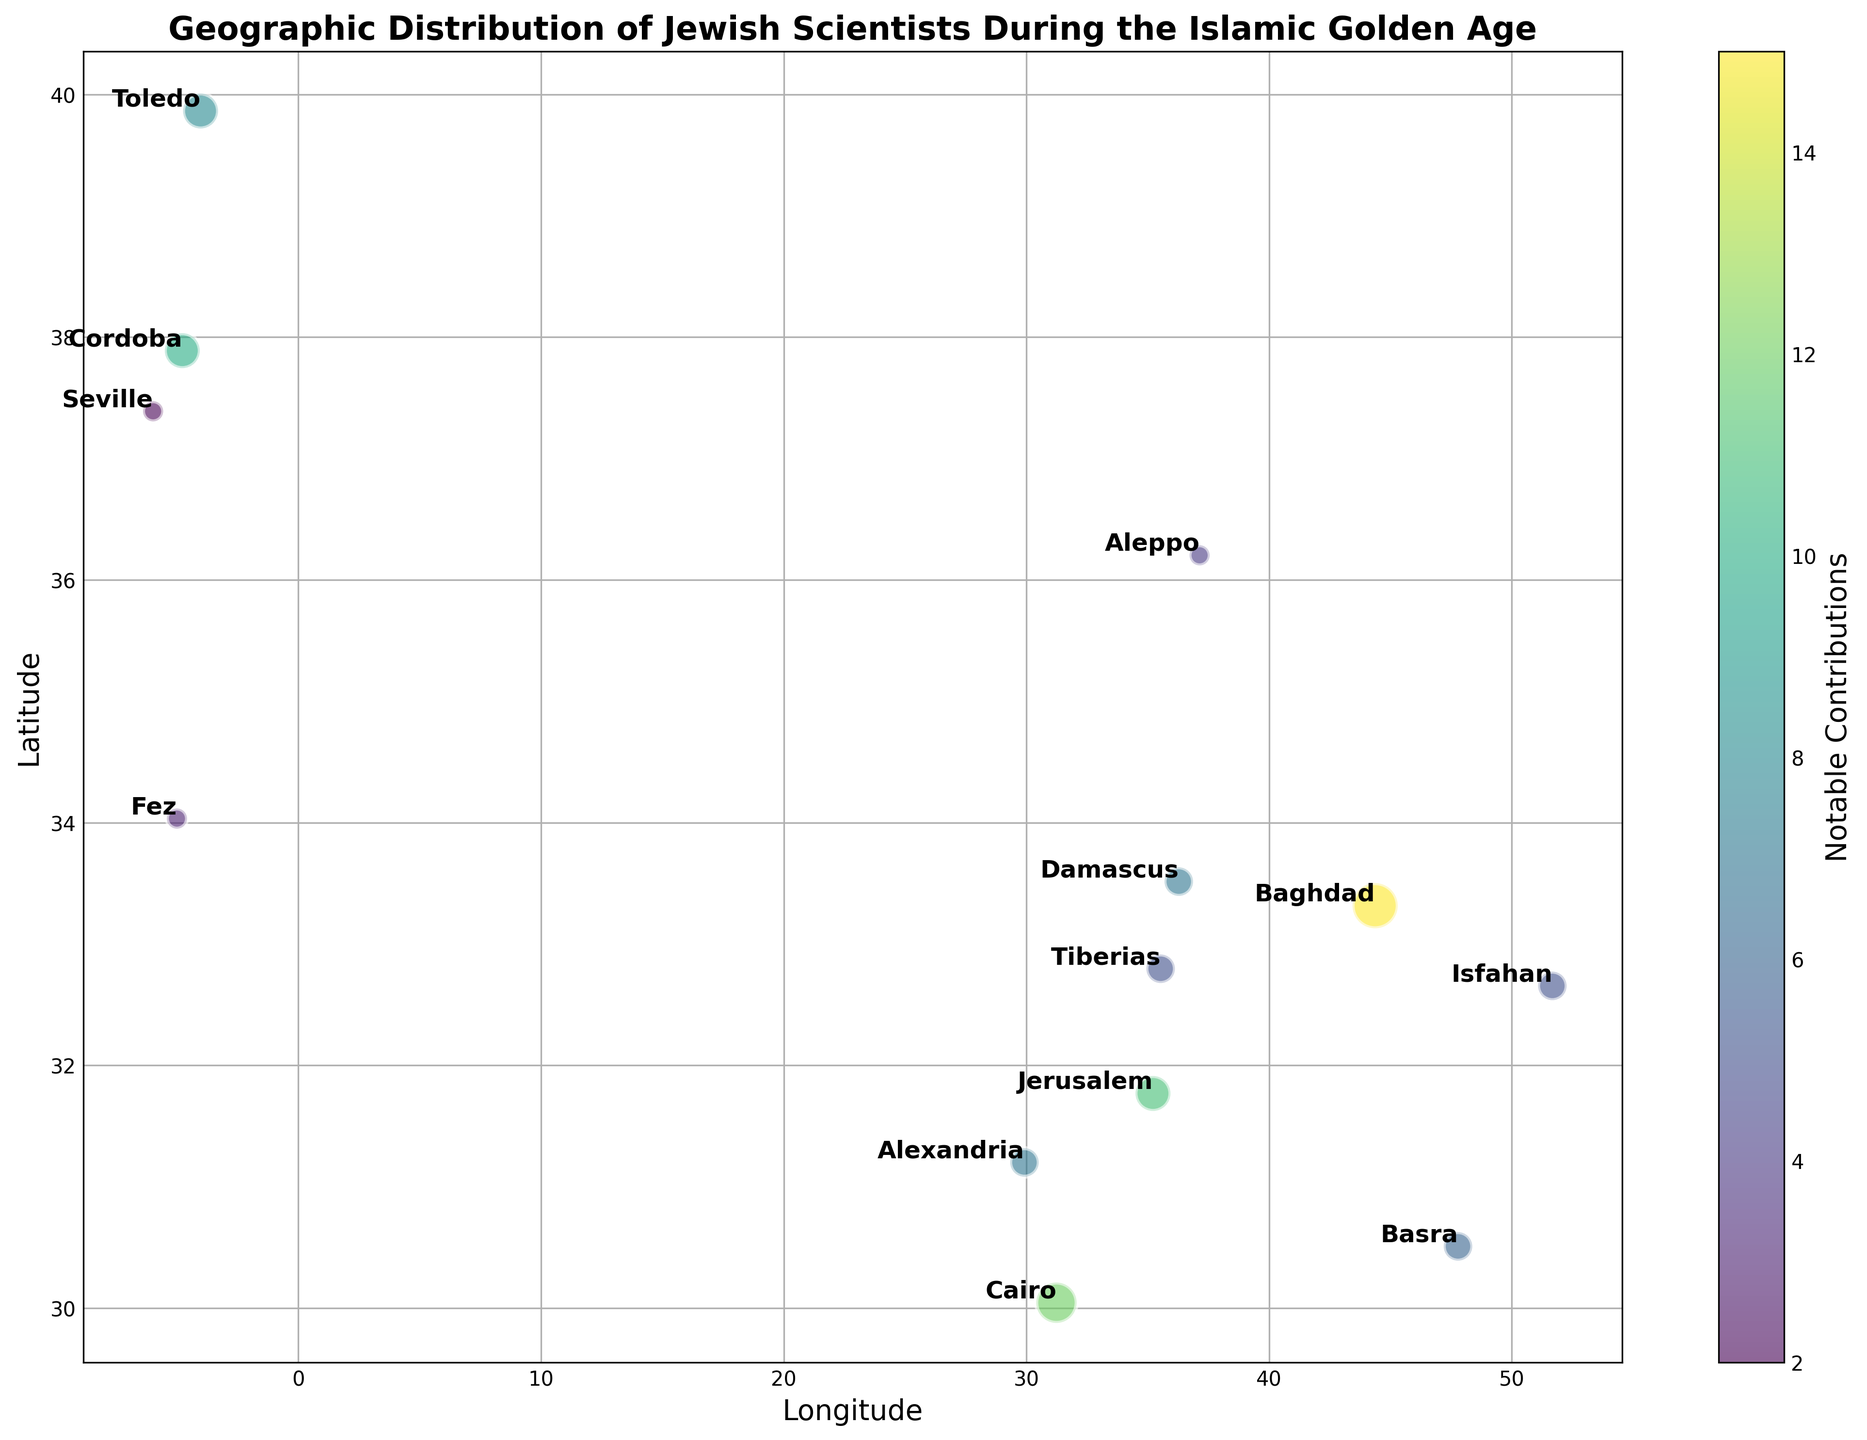What city has the highest number of Jewish scientists? Baghdad has the largest bubble size, indicating it has the highest number of Jewish scientists.
Answer: Baghdad Which city has the most notable contributions? Baghdad’s bubble is the darkest among all, indicating it has the highest notable contributions.
Answer: Baghdad Compare the number of Jewish scientists in Alexandria and Fez. Which city has more? The bubble for Alexandria is larger than Fez's bubble, showing Alexandria has more Jewish scientists.
Answer: Alexandria Which location has more notable contributions, Cordoba or Toledo? Cordoba's bubble is darker than Toledo's, indicating Cordoba has more notable contributions.
Answer: Cordoba What is the combined number of Jewish scientists from Cairo and Jerusalem? Cairo has 4 Jewish scientists and Jerusalem has 3, so the combined number is 4 + 3.
Answer: 7 Between Cairo and Cordoba, which city has less notable contributions? Cordoba's bubble is lighter than Cairo's, indicating Cordoba has fewer notable contributions.
Answer: Cordoba What is the total number of Jewish scientists in all cities shown? Adding the number of scientists from all cities (5+3+4+2+3+2+1+1+2+3+2+1+2), we get a total of 31.
Answer: 31 Compare the notable contributions between Seville and Fez. Which city has fewer? Seville's bubble is lighter than Fez's, indicating Seville has fewer notable contributions.
Answer: Seville Which cities have an equal number of Jewish scientists? Tiberias, Basra, and Isfahan each have 2 scientists, and Cordoba and Toledo each have 3 scientists.
Answer: Tiberias, Basra, Isfahan, Cordoba, Toledo 